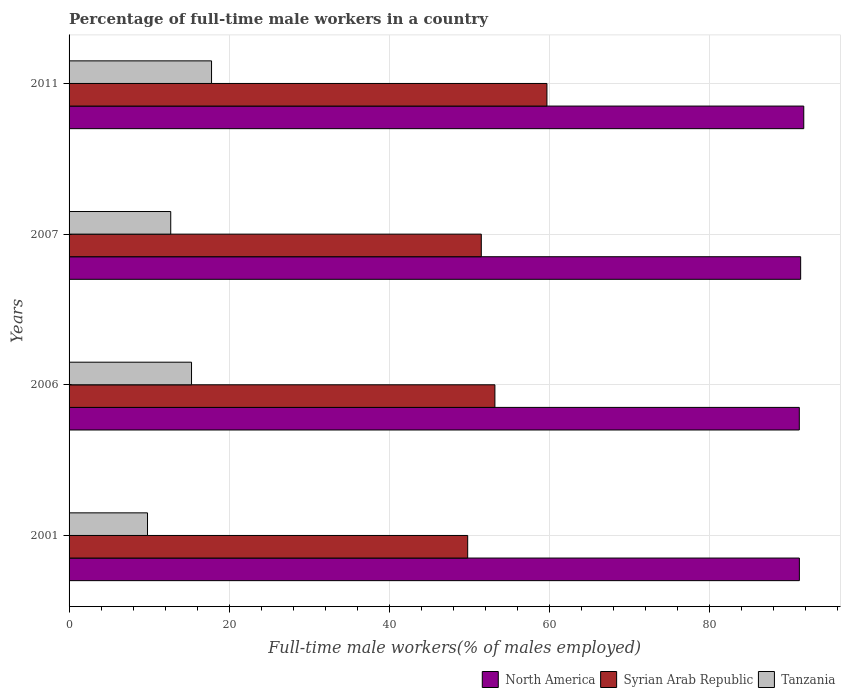How many different coloured bars are there?
Provide a short and direct response. 3. How many groups of bars are there?
Your response must be concise. 4. Are the number of bars on each tick of the Y-axis equal?
Your response must be concise. Yes. How many bars are there on the 2nd tick from the top?
Offer a very short reply. 3. How many bars are there on the 1st tick from the bottom?
Make the answer very short. 3. What is the label of the 3rd group of bars from the top?
Your response must be concise. 2006. In how many cases, is the number of bars for a given year not equal to the number of legend labels?
Your answer should be compact. 0. What is the percentage of full-time male workers in Syrian Arab Republic in 2007?
Keep it short and to the point. 51.5. Across all years, what is the maximum percentage of full-time male workers in Tanzania?
Keep it short and to the point. 17.8. Across all years, what is the minimum percentage of full-time male workers in Tanzania?
Your answer should be compact. 9.8. In which year was the percentage of full-time male workers in Syrian Arab Republic maximum?
Offer a terse response. 2011. What is the total percentage of full-time male workers in North America in the graph?
Your answer should be compact. 365.65. What is the difference between the percentage of full-time male workers in North America in 2001 and that in 2007?
Keep it short and to the point. -0.16. What is the difference between the percentage of full-time male workers in North America in 2007 and the percentage of full-time male workers in Tanzania in 2001?
Your response must be concise. 81.6. What is the average percentage of full-time male workers in North America per year?
Keep it short and to the point. 91.41. In the year 2011, what is the difference between the percentage of full-time male workers in Syrian Arab Republic and percentage of full-time male workers in North America?
Offer a very short reply. -32.09. In how many years, is the percentage of full-time male workers in North America greater than 60 %?
Offer a terse response. 4. What is the ratio of the percentage of full-time male workers in North America in 2007 to that in 2011?
Make the answer very short. 1. Is the percentage of full-time male workers in North America in 2001 less than that in 2011?
Ensure brevity in your answer.  Yes. What is the difference between the highest and the second highest percentage of full-time male workers in Tanzania?
Your answer should be compact. 2.5. What is the difference between the highest and the lowest percentage of full-time male workers in Syrian Arab Republic?
Provide a succinct answer. 9.9. What does the 1st bar from the top in 2001 represents?
Your response must be concise. Tanzania. What does the 3rd bar from the bottom in 2001 represents?
Your answer should be very brief. Tanzania. Are all the bars in the graph horizontal?
Your response must be concise. Yes. What is the difference between two consecutive major ticks on the X-axis?
Your answer should be very brief. 20. Does the graph contain grids?
Provide a short and direct response. Yes. How many legend labels are there?
Offer a very short reply. 3. What is the title of the graph?
Your response must be concise. Percentage of full-time male workers in a country. What is the label or title of the X-axis?
Give a very brief answer. Full-time male workers(% of males employed). What is the label or title of the Y-axis?
Make the answer very short. Years. What is the Full-time male workers(% of males employed) of North America in 2001?
Offer a terse response. 91.24. What is the Full-time male workers(% of males employed) of Syrian Arab Republic in 2001?
Make the answer very short. 49.8. What is the Full-time male workers(% of males employed) in Tanzania in 2001?
Give a very brief answer. 9.8. What is the Full-time male workers(% of males employed) of North America in 2006?
Make the answer very short. 91.23. What is the Full-time male workers(% of males employed) in Syrian Arab Republic in 2006?
Your response must be concise. 53.2. What is the Full-time male workers(% of males employed) of Tanzania in 2006?
Your answer should be very brief. 15.3. What is the Full-time male workers(% of males employed) in North America in 2007?
Provide a succinct answer. 91.4. What is the Full-time male workers(% of males employed) in Syrian Arab Republic in 2007?
Your answer should be very brief. 51.5. What is the Full-time male workers(% of males employed) of Tanzania in 2007?
Offer a very short reply. 12.7. What is the Full-time male workers(% of males employed) in North America in 2011?
Offer a terse response. 91.79. What is the Full-time male workers(% of males employed) of Syrian Arab Republic in 2011?
Your response must be concise. 59.7. What is the Full-time male workers(% of males employed) in Tanzania in 2011?
Ensure brevity in your answer.  17.8. Across all years, what is the maximum Full-time male workers(% of males employed) in North America?
Your response must be concise. 91.79. Across all years, what is the maximum Full-time male workers(% of males employed) in Syrian Arab Republic?
Ensure brevity in your answer.  59.7. Across all years, what is the maximum Full-time male workers(% of males employed) in Tanzania?
Provide a succinct answer. 17.8. Across all years, what is the minimum Full-time male workers(% of males employed) of North America?
Make the answer very short. 91.23. Across all years, what is the minimum Full-time male workers(% of males employed) of Syrian Arab Republic?
Give a very brief answer. 49.8. Across all years, what is the minimum Full-time male workers(% of males employed) of Tanzania?
Provide a succinct answer. 9.8. What is the total Full-time male workers(% of males employed) of North America in the graph?
Your response must be concise. 365.65. What is the total Full-time male workers(% of males employed) in Syrian Arab Republic in the graph?
Your response must be concise. 214.2. What is the total Full-time male workers(% of males employed) of Tanzania in the graph?
Provide a short and direct response. 55.6. What is the difference between the Full-time male workers(% of males employed) in North America in 2001 and that in 2006?
Keep it short and to the point. 0.01. What is the difference between the Full-time male workers(% of males employed) of Syrian Arab Republic in 2001 and that in 2006?
Keep it short and to the point. -3.4. What is the difference between the Full-time male workers(% of males employed) in North America in 2001 and that in 2007?
Offer a very short reply. -0.16. What is the difference between the Full-time male workers(% of males employed) in North America in 2001 and that in 2011?
Offer a terse response. -0.55. What is the difference between the Full-time male workers(% of males employed) in Tanzania in 2001 and that in 2011?
Your response must be concise. -8. What is the difference between the Full-time male workers(% of males employed) in North America in 2006 and that in 2007?
Make the answer very short. -0.17. What is the difference between the Full-time male workers(% of males employed) in Tanzania in 2006 and that in 2007?
Provide a short and direct response. 2.6. What is the difference between the Full-time male workers(% of males employed) in North America in 2006 and that in 2011?
Offer a terse response. -0.56. What is the difference between the Full-time male workers(% of males employed) in North America in 2007 and that in 2011?
Make the answer very short. -0.39. What is the difference between the Full-time male workers(% of males employed) of Tanzania in 2007 and that in 2011?
Give a very brief answer. -5.1. What is the difference between the Full-time male workers(% of males employed) of North America in 2001 and the Full-time male workers(% of males employed) of Syrian Arab Republic in 2006?
Your response must be concise. 38.04. What is the difference between the Full-time male workers(% of males employed) in North America in 2001 and the Full-time male workers(% of males employed) in Tanzania in 2006?
Your answer should be compact. 75.94. What is the difference between the Full-time male workers(% of males employed) in Syrian Arab Republic in 2001 and the Full-time male workers(% of males employed) in Tanzania in 2006?
Give a very brief answer. 34.5. What is the difference between the Full-time male workers(% of males employed) in North America in 2001 and the Full-time male workers(% of males employed) in Syrian Arab Republic in 2007?
Your answer should be very brief. 39.74. What is the difference between the Full-time male workers(% of males employed) of North America in 2001 and the Full-time male workers(% of males employed) of Tanzania in 2007?
Your answer should be very brief. 78.54. What is the difference between the Full-time male workers(% of males employed) in Syrian Arab Republic in 2001 and the Full-time male workers(% of males employed) in Tanzania in 2007?
Keep it short and to the point. 37.1. What is the difference between the Full-time male workers(% of males employed) in North America in 2001 and the Full-time male workers(% of males employed) in Syrian Arab Republic in 2011?
Your response must be concise. 31.54. What is the difference between the Full-time male workers(% of males employed) in North America in 2001 and the Full-time male workers(% of males employed) in Tanzania in 2011?
Keep it short and to the point. 73.44. What is the difference between the Full-time male workers(% of males employed) in North America in 2006 and the Full-time male workers(% of males employed) in Syrian Arab Republic in 2007?
Offer a very short reply. 39.73. What is the difference between the Full-time male workers(% of males employed) in North America in 2006 and the Full-time male workers(% of males employed) in Tanzania in 2007?
Ensure brevity in your answer.  78.53. What is the difference between the Full-time male workers(% of males employed) in Syrian Arab Republic in 2006 and the Full-time male workers(% of males employed) in Tanzania in 2007?
Provide a short and direct response. 40.5. What is the difference between the Full-time male workers(% of males employed) of North America in 2006 and the Full-time male workers(% of males employed) of Syrian Arab Republic in 2011?
Make the answer very short. 31.53. What is the difference between the Full-time male workers(% of males employed) in North America in 2006 and the Full-time male workers(% of males employed) in Tanzania in 2011?
Your answer should be very brief. 73.43. What is the difference between the Full-time male workers(% of males employed) in Syrian Arab Republic in 2006 and the Full-time male workers(% of males employed) in Tanzania in 2011?
Provide a short and direct response. 35.4. What is the difference between the Full-time male workers(% of males employed) in North America in 2007 and the Full-time male workers(% of males employed) in Syrian Arab Republic in 2011?
Make the answer very short. 31.7. What is the difference between the Full-time male workers(% of males employed) in North America in 2007 and the Full-time male workers(% of males employed) in Tanzania in 2011?
Make the answer very short. 73.6. What is the difference between the Full-time male workers(% of males employed) of Syrian Arab Republic in 2007 and the Full-time male workers(% of males employed) of Tanzania in 2011?
Keep it short and to the point. 33.7. What is the average Full-time male workers(% of males employed) of North America per year?
Provide a short and direct response. 91.41. What is the average Full-time male workers(% of males employed) in Syrian Arab Republic per year?
Your answer should be very brief. 53.55. In the year 2001, what is the difference between the Full-time male workers(% of males employed) in North America and Full-time male workers(% of males employed) in Syrian Arab Republic?
Provide a short and direct response. 41.44. In the year 2001, what is the difference between the Full-time male workers(% of males employed) of North America and Full-time male workers(% of males employed) of Tanzania?
Your response must be concise. 81.44. In the year 2006, what is the difference between the Full-time male workers(% of males employed) of North America and Full-time male workers(% of males employed) of Syrian Arab Republic?
Offer a terse response. 38.03. In the year 2006, what is the difference between the Full-time male workers(% of males employed) in North America and Full-time male workers(% of males employed) in Tanzania?
Offer a very short reply. 75.93. In the year 2006, what is the difference between the Full-time male workers(% of males employed) of Syrian Arab Republic and Full-time male workers(% of males employed) of Tanzania?
Your answer should be very brief. 37.9. In the year 2007, what is the difference between the Full-time male workers(% of males employed) in North America and Full-time male workers(% of males employed) in Syrian Arab Republic?
Give a very brief answer. 39.9. In the year 2007, what is the difference between the Full-time male workers(% of males employed) of North America and Full-time male workers(% of males employed) of Tanzania?
Give a very brief answer. 78.7. In the year 2007, what is the difference between the Full-time male workers(% of males employed) of Syrian Arab Republic and Full-time male workers(% of males employed) of Tanzania?
Offer a very short reply. 38.8. In the year 2011, what is the difference between the Full-time male workers(% of males employed) in North America and Full-time male workers(% of males employed) in Syrian Arab Republic?
Ensure brevity in your answer.  32.09. In the year 2011, what is the difference between the Full-time male workers(% of males employed) in North America and Full-time male workers(% of males employed) in Tanzania?
Offer a terse response. 73.99. In the year 2011, what is the difference between the Full-time male workers(% of males employed) of Syrian Arab Republic and Full-time male workers(% of males employed) of Tanzania?
Make the answer very short. 41.9. What is the ratio of the Full-time male workers(% of males employed) in North America in 2001 to that in 2006?
Offer a very short reply. 1. What is the ratio of the Full-time male workers(% of males employed) of Syrian Arab Republic in 2001 to that in 2006?
Your answer should be compact. 0.94. What is the ratio of the Full-time male workers(% of males employed) of Tanzania in 2001 to that in 2006?
Offer a terse response. 0.64. What is the ratio of the Full-time male workers(% of males employed) in Syrian Arab Republic in 2001 to that in 2007?
Provide a succinct answer. 0.97. What is the ratio of the Full-time male workers(% of males employed) in Tanzania in 2001 to that in 2007?
Offer a terse response. 0.77. What is the ratio of the Full-time male workers(% of males employed) in North America in 2001 to that in 2011?
Make the answer very short. 0.99. What is the ratio of the Full-time male workers(% of males employed) in Syrian Arab Republic in 2001 to that in 2011?
Offer a very short reply. 0.83. What is the ratio of the Full-time male workers(% of males employed) of Tanzania in 2001 to that in 2011?
Keep it short and to the point. 0.55. What is the ratio of the Full-time male workers(% of males employed) in Syrian Arab Republic in 2006 to that in 2007?
Provide a succinct answer. 1.03. What is the ratio of the Full-time male workers(% of males employed) in Tanzania in 2006 to that in 2007?
Provide a succinct answer. 1.2. What is the ratio of the Full-time male workers(% of males employed) of Syrian Arab Republic in 2006 to that in 2011?
Your answer should be very brief. 0.89. What is the ratio of the Full-time male workers(% of males employed) in Tanzania in 2006 to that in 2011?
Offer a very short reply. 0.86. What is the ratio of the Full-time male workers(% of males employed) in North America in 2007 to that in 2011?
Make the answer very short. 1. What is the ratio of the Full-time male workers(% of males employed) in Syrian Arab Republic in 2007 to that in 2011?
Offer a terse response. 0.86. What is the ratio of the Full-time male workers(% of males employed) of Tanzania in 2007 to that in 2011?
Give a very brief answer. 0.71. What is the difference between the highest and the second highest Full-time male workers(% of males employed) of North America?
Provide a succinct answer. 0.39. What is the difference between the highest and the second highest Full-time male workers(% of males employed) of Syrian Arab Republic?
Provide a succinct answer. 6.5. What is the difference between the highest and the second highest Full-time male workers(% of males employed) in Tanzania?
Your answer should be very brief. 2.5. What is the difference between the highest and the lowest Full-time male workers(% of males employed) in North America?
Your answer should be compact. 0.56. What is the difference between the highest and the lowest Full-time male workers(% of males employed) in Syrian Arab Republic?
Keep it short and to the point. 9.9. 